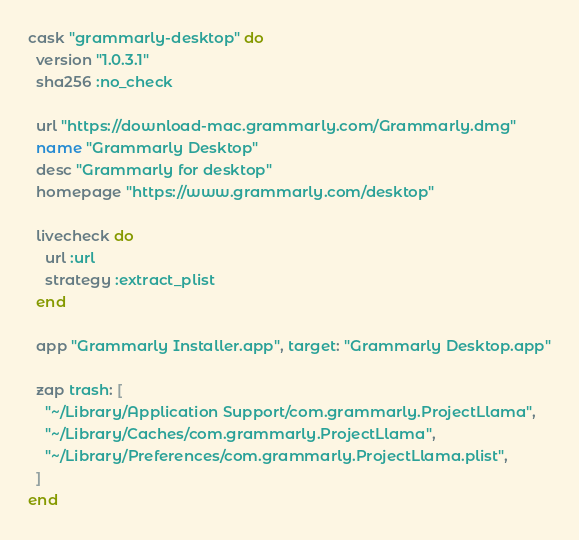<code> <loc_0><loc_0><loc_500><loc_500><_Ruby_>cask "grammarly-desktop" do
  version "1.0.3.1"
  sha256 :no_check

  url "https://download-mac.grammarly.com/Grammarly.dmg"
  name "Grammarly Desktop"
  desc "Grammarly for desktop"
  homepage "https://www.grammarly.com/desktop"

  livecheck do
    url :url
    strategy :extract_plist
  end

  app "Grammarly Installer.app", target: "Grammarly Desktop.app"

  zap trash: [
    "~/Library/Application Support/com.grammarly.ProjectLlama",
    "~/Library/Caches/com.grammarly.ProjectLlama",
    "~/Library/Preferences/com.grammarly.ProjectLlama.plist",
  ]
end
</code> 